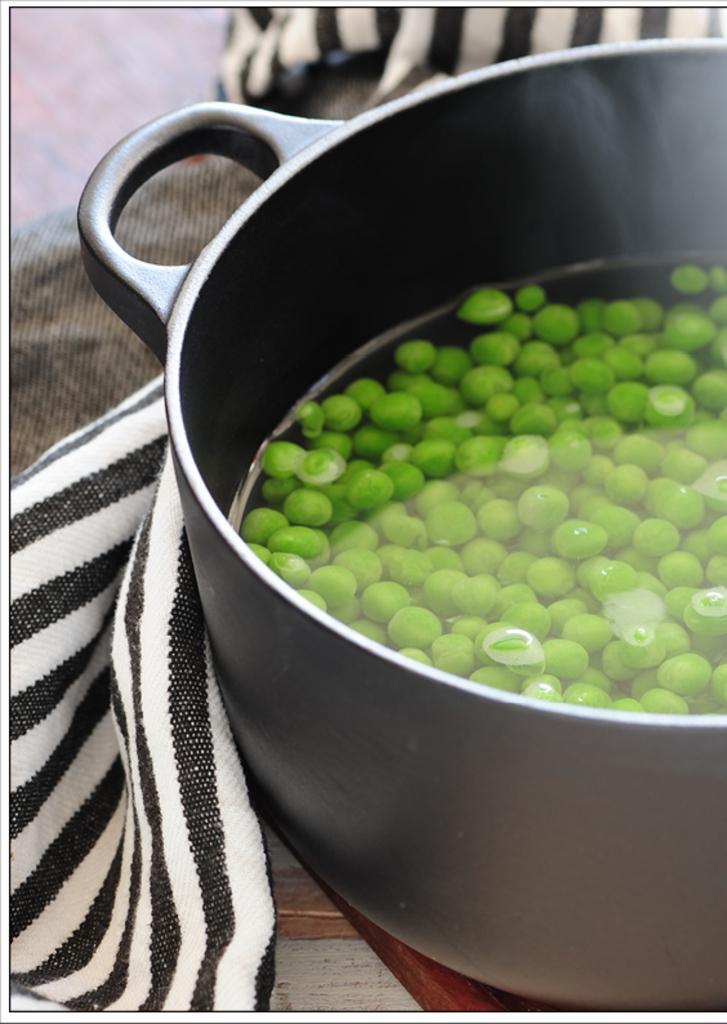Can you describe this image briefly? We can see bowl with water and green pulses and cloth on the surface. 